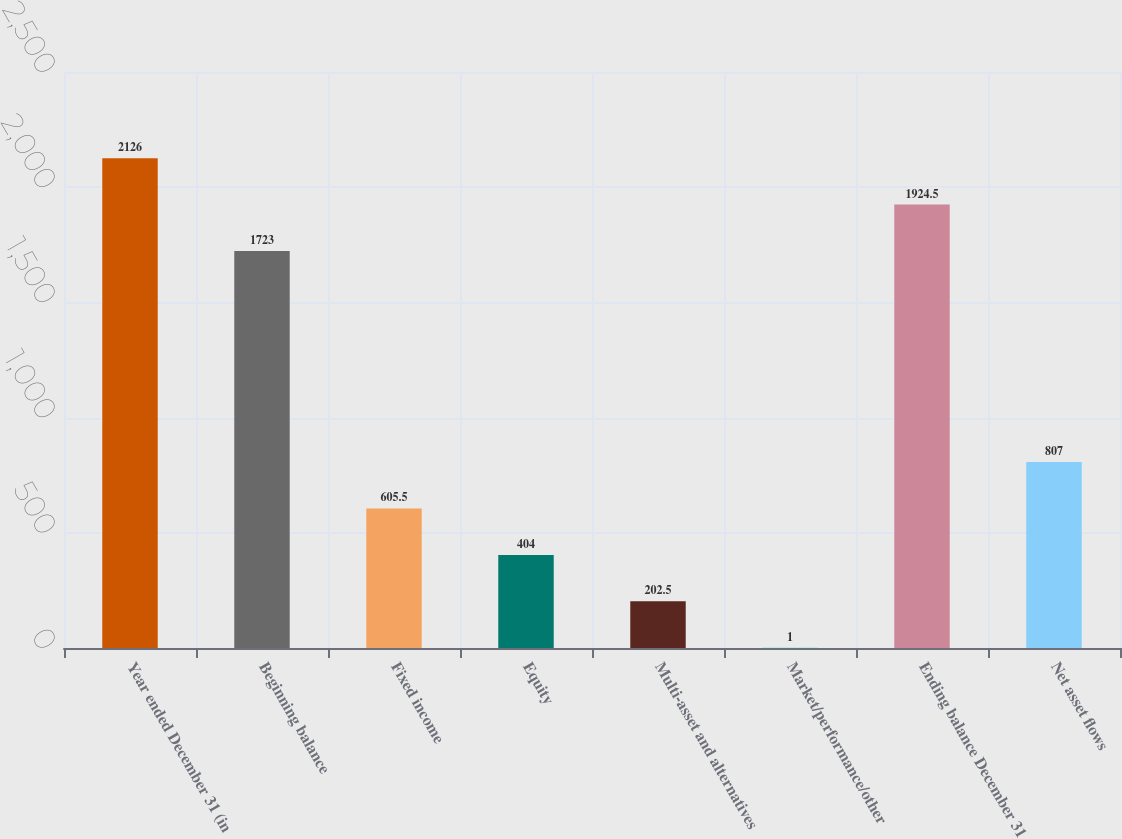Convert chart. <chart><loc_0><loc_0><loc_500><loc_500><bar_chart><fcel>Year ended December 31 (in<fcel>Beginning balance<fcel>Fixed income<fcel>Equity<fcel>Multi-asset and alternatives<fcel>Market/performance/other<fcel>Ending balance December 31<fcel>Net asset flows<nl><fcel>2126<fcel>1723<fcel>605.5<fcel>404<fcel>202.5<fcel>1<fcel>1924.5<fcel>807<nl></chart> 